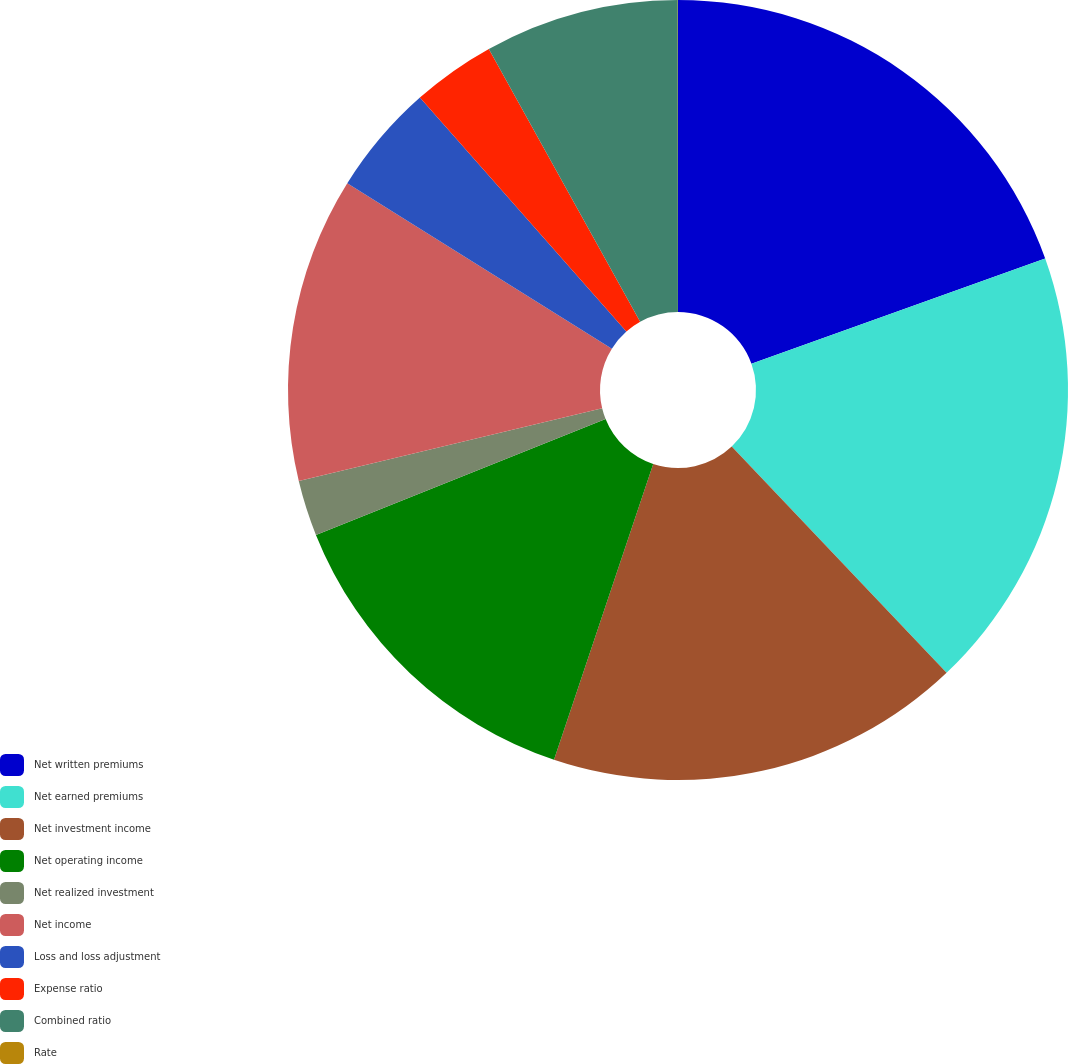<chart> <loc_0><loc_0><loc_500><loc_500><pie_chart><fcel>Net written premiums<fcel>Net earned premiums<fcel>Net investment income<fcel>Net operating income<fcel>Net realized investment<fcel>Net income<fcel>Loss and loss adjustment<fcel>Expense ratio<fcel>Combined ratio<fcel>Rate<nl><fcel>19.53%<fcel>18.38%<fcel>17.24%<fcel>13.79%<fcel>2.31%<fcel>12.64%<fcel>4.6%<fcel>3.45%<fcel>8.05%<fcel>0.01%<nl></chart> 